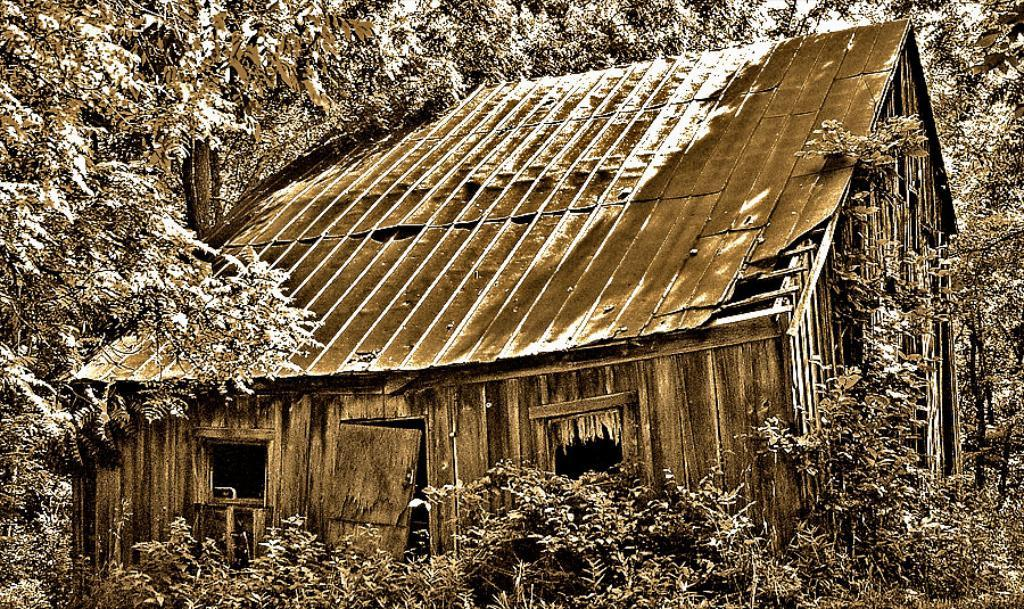What type of vegetation can be seen in the image? There are trees in the image. What is covering the trees and the house? There is snow on the trees and the roof of the house. Can you describe the color of the house? The house is brown-colored. Where is the house located in relation to the trees? The house is located between the trees. What type of art can be seen on the map in the image? There is no map present in the image, so it is not possible to determine if there is any art on it. 